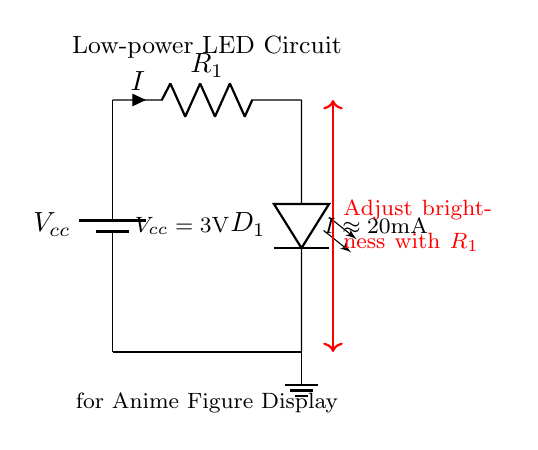What is the voltage of this circuit? The voltage is three volts, which is clearly labeled as Vcc in the circuit diagram. This voltage serves as the power supply for the LED circuit.
Answer: three volts What is the purpose of the resistor in this circuit? The current limiting resistor, R1, is used to regulate the amount of current flowing to the LED. It prevents excessive current that could damage the LED. This is essential in LED circuits to ensure longevity and proper function.
Answer: regulate current What is the current flowing through the LED? The current flowing through the LED is approximately twenty milliamperes, as indicated in the circuit diagram. This value is commonly used for standard LEDs to ensure they light properly without burning out.
Answer: twenty milliamperes How can I adjust the brightness of the LED? The brightness of the LED can be adjusted by changing the value of the resistor R1. A higher resistance will result in less current flowing through the LED, decreasing its brightness, while a lower resistance will increase the current, making it brighter.
Answer: by changing R1 What type of component is D1 in this circuit? D1 is a light-emitting diode, commonly known as an LED. It is specifically designed to emit light when current flows through it in the correct direction and is a key component in this low-power circuit for illuminating displays.
Answer: LED What kind of circuit is this? This is a low-power LED circuit, designed for illuminating display items such as anime figures. It is optimized to use minimal power while providing sufficient light output for decorative purposes.
Answer: low-power LED circuit 